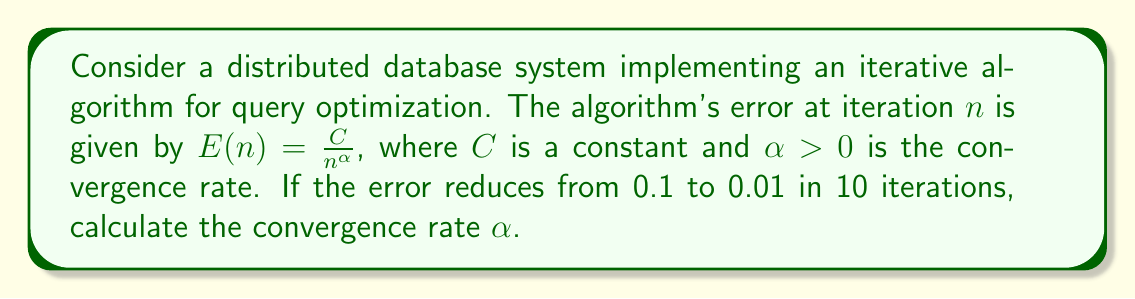Can you solve this math problem? Let's approach this step-by-step:

1) We're given that $E(n) = \frac{C}{n^\alpha}$

2) At the start (let's call this iteration $n_1$), $E(n_1) = 0.1$
   At the end (after 10 more iterations, $n_2 = n_1 + 10$), $E(n_2) = 0.01$

3) We can write two equations:

   $$0.1 = \frac{C}{n_1^\alpha}$$
   $$0.01 = \frac{C}{(n_1 + 10)^\alpha}$$

4) Dividing these equations:

   $$\frac{0.1}{0.01} = \frac{(n_1 + 10)^\alpha}{n_1^\alpha}$$

5) Simplifying:

   $$10 = \left(\frac{n_1 + 10}{n_1}\right)^\alpha$$

6) Taking the natural log of both sides:

   $$\ln(10) = \alpha \ln\left(\frac{n_1 + 10}{n_1}\right)$$

7) Solving for $\alpha$:

   $$\alpha = \frac{\ln(10)}{\ln\left(\frac{n_1 + 10}{n_1}\right)}$$

8) We don't know $n_1$, but we can see that as $n_1$ increases, $\frac{n_1 + 10}{n_1}$ approaches 1, and $\alpha$ increases.

9) The minimum value of $\alpha$ occurs when $n_1 = 1$:

   $$\alpha_{min} = \frac{\ln(10)}{\ln(11)} \approx 2.3$$

Therefore, the convergence rate $\alpha$ must be at least 2.3.
Answer: $\alpha \geq 2.3$ 